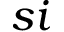<formula> <loc_0><loc_0><loc_500><loc_500>s i</formula> 